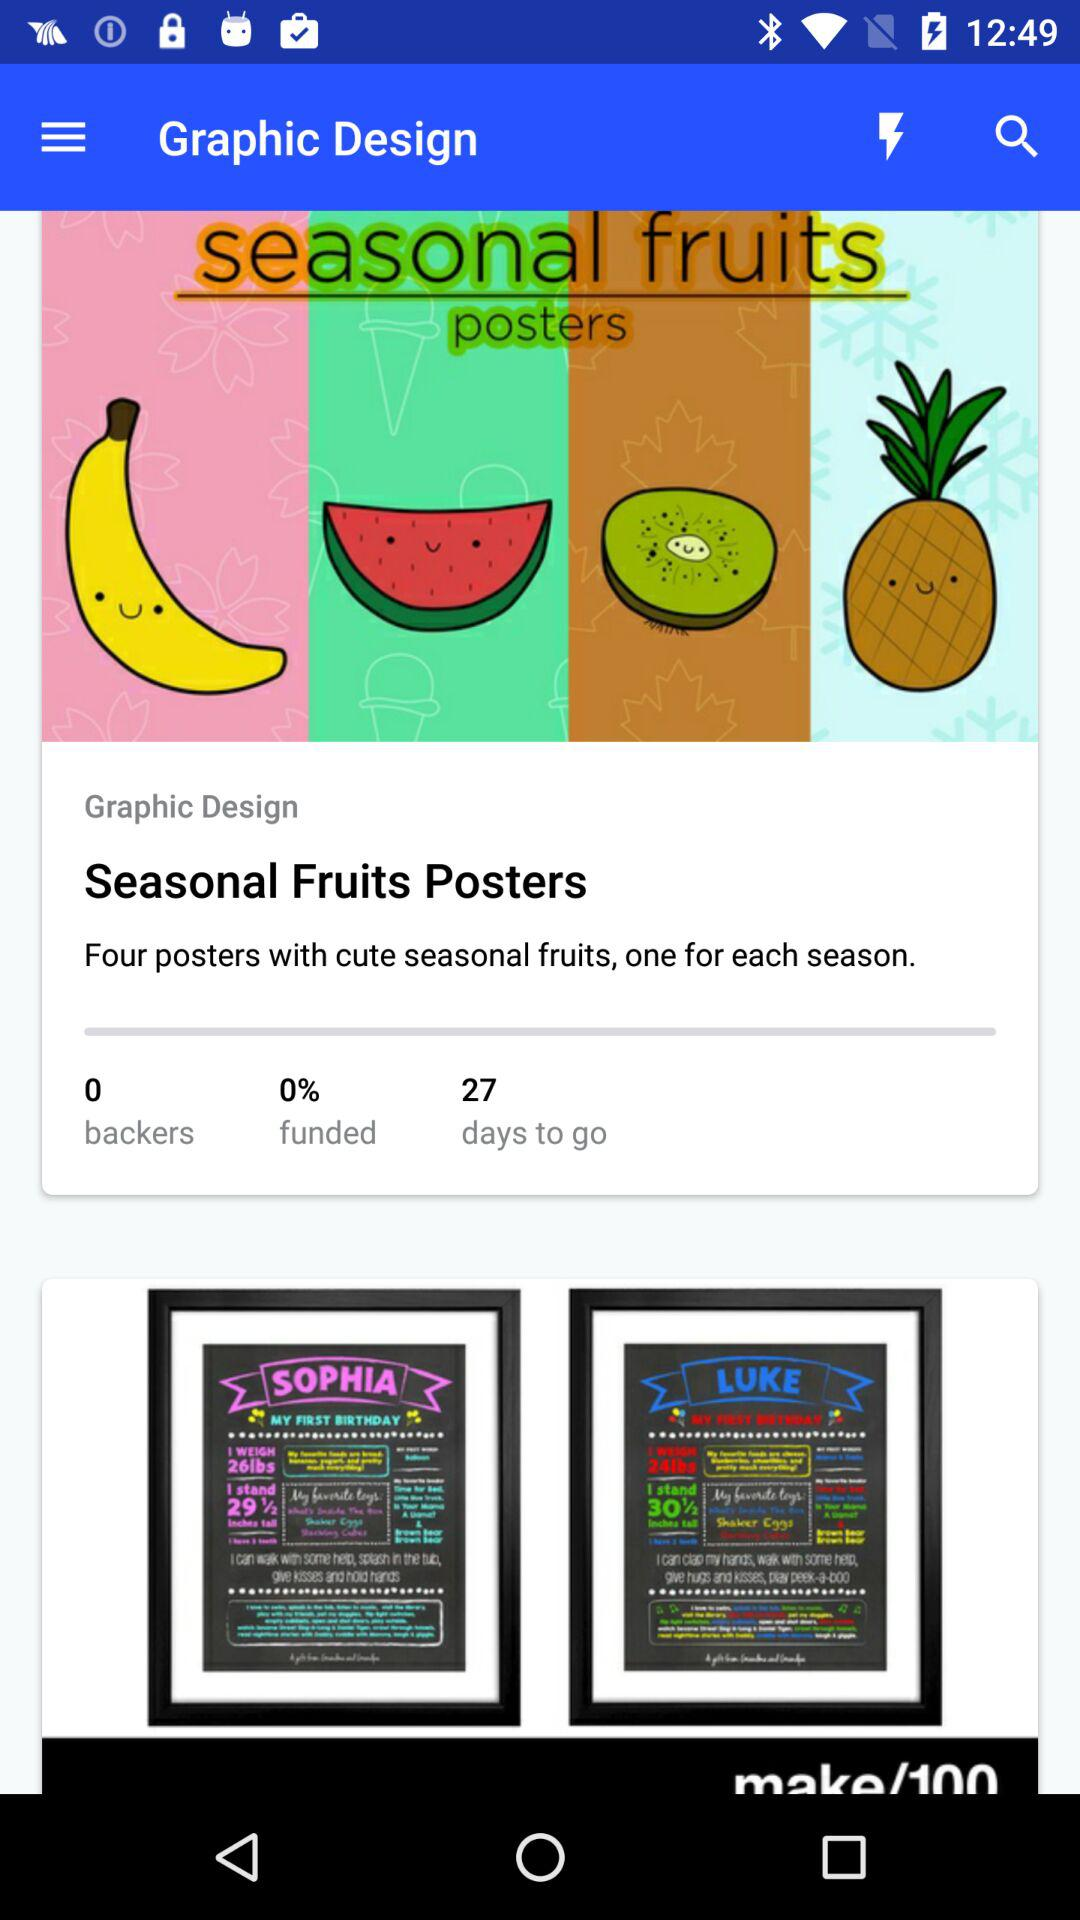What is the overall number of backers?
Answer the question using a single word or phrase. The overall number of backers is 0 